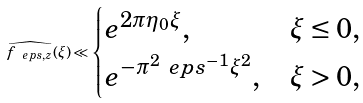<formula> <loc_0><loc_0><loc_500><loc_500>\widehat { f _ { \ e p s , z } } ( \xi ) \ll \begin{cases} e ^ { 2 \pi \eta _ { 0 } \xi } , & \xi \leq 0 , \\ e ^ { - \pi ^ { 2 } \ e p s ^ { - 1 } \xi ^ { 2 } } , & \xi > 0 , \end{cases}</formula> 